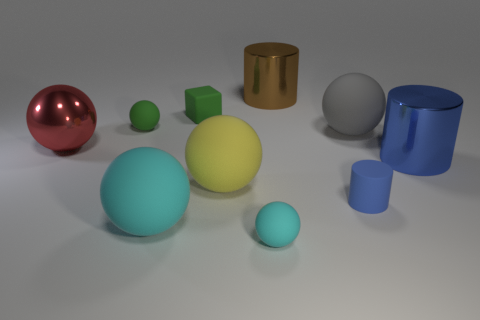Subtract all tiny blue cylinders. How many cylinders are left? 2 Subtract all brown cylinders. How many cylinders are left? 2 Subtract all spheres. How many objects are left? 4 Add 4 gray things. How many gray things exist? 5 Subtract 0 blue blocks. How many objects are left? 10 Subtract 1 cylinders. How many cylinders are left? 2 Subtract all purple cylinders. Subtract all cyan spheres. How many cylinders are left? 3 Subtract all blue cubes. How many brown cylinders are left? 1 Subtract all shiny things. Subtract all matte cylinders. How many objects are left? 6 Add 8 large cylinders. How many large cylinders are left? 10 